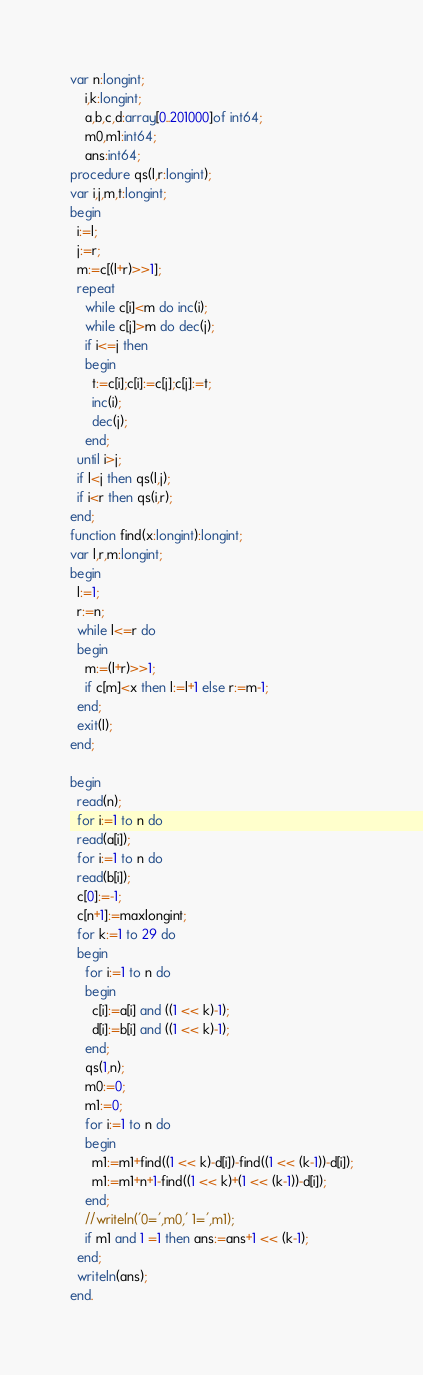<code> <loc_0><loc_0><loc_500><loc_500><_Pascal_>var n:longint;
    i,k:longint;
    a,b,c,d:array[0..201000]of int64;
    m0,m1:int64;
    ans:int64;
procedure qs(l,r:longint);
var i,j,m,t:longint;
begin
  i:=l;
  j:=r;
  m:=c[(l+r)>>1];
  repeat
    while c[i]<m do inc(i);
    while c[j]>m do dec(j);
    if i<=j then
    begin
      t:=c[i];c[i]:=c[j];c[j]:=t;
      inc(i);
      dec(j);
    end;
  until i>j;
  if l<j then qs(l,j);
  if i<r then qs(i,r);
end;
function find(x:longint):longint;
var l,r,m:longint;
begin
  l:=1;
  r:=n;
  while l<=r do
  begin
    m:=(l+r)>>1;
    if c[m]<x then l:=l+1 else r:=m-1;
  end;
  exit(l);
end;

begin
  read(n);
  for i:=1 to n do
  read(a[i]);
  for i:=1 to n do
  read(b[i]);
  c[0]:=-1;
  c[n+1]:=maxlongint;
  for k:=1 to 29 do
  begin
    for i:=1 to n do
    begin
      c[i]:=a[i] and ((1 << k)-1);
      d[i]:=b[i] and ((1 << k)-1);
    end;
    qs(1,n);
    m0:=0;
    m1:=0;
    for i:=1 to n do
    begin
      m1:=m1+find((1 << k)-d[i])-find((1 << (k-1))-d[i]);
      m1:=m1+n+1-find((1 << k)+(1 << (k-1))-d[i]);
    end;
    //writeln('0=',m0,' 1=',m1);
    if m1 and 1 =1 then ans:=ans+1 << (k-1);
  end;
  writeln(ans);
end.




</code> 